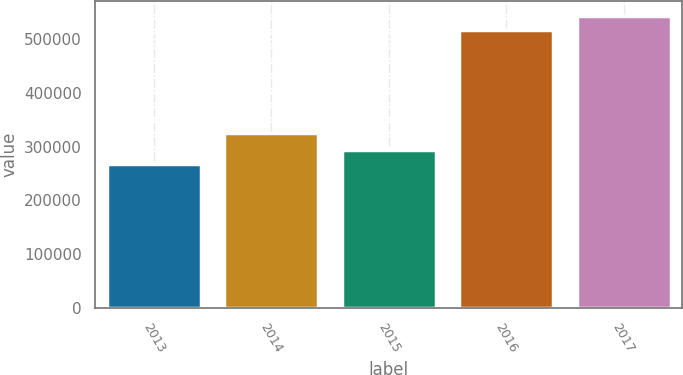<chart> <loc_0><loc_0><loc_500><loc_500><bar_chart><fcel>2013<fcel>2014<fcel>2015<fcel>2016<fcel>2017<nl><fcel>268599<fcel>325413<fcel>294582<fcel>517291<fcel>543274<nl></chart> 